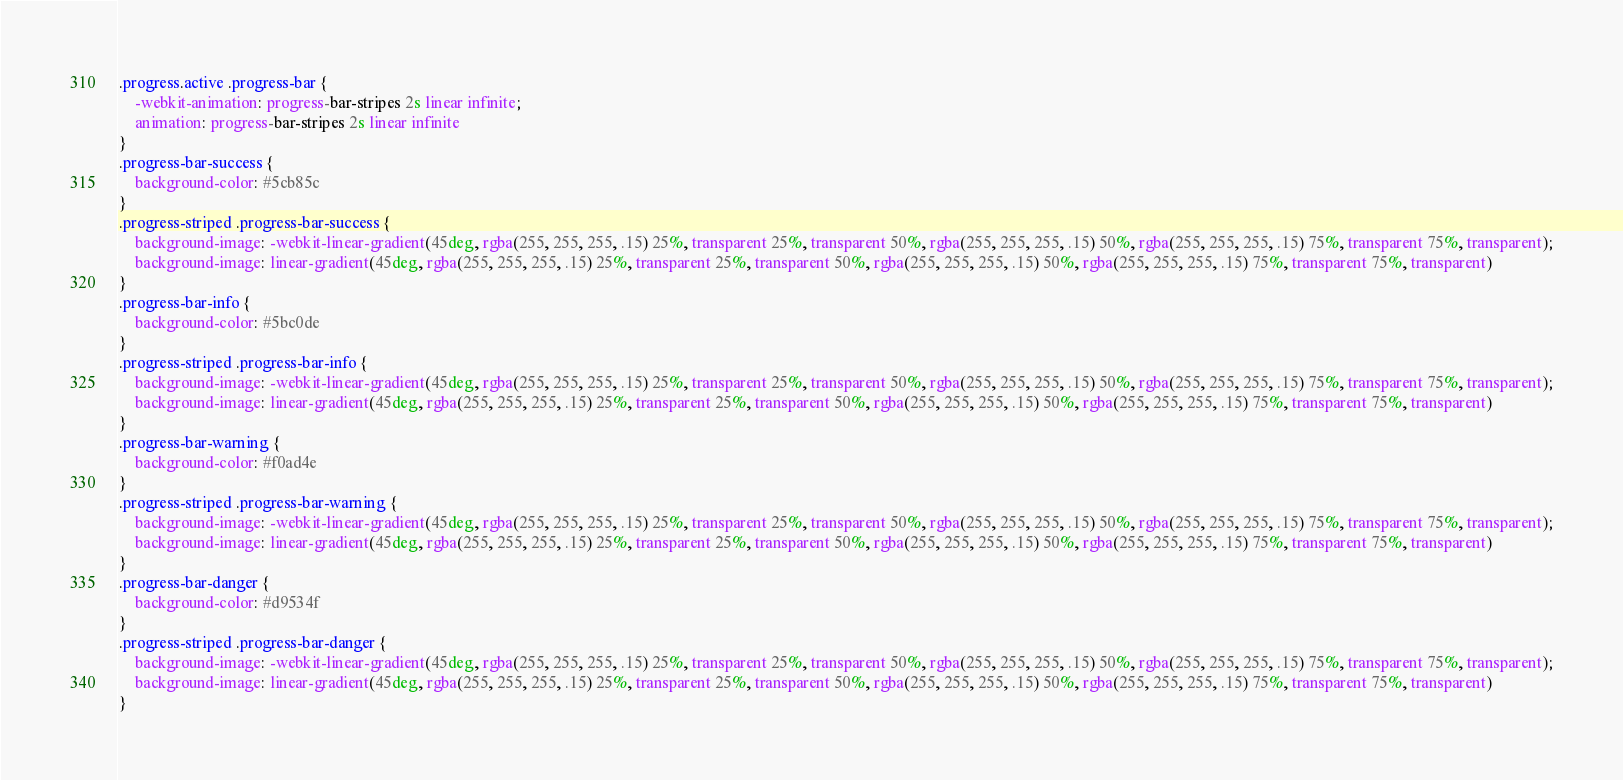<code> <loc_0><loc_0><loc_500><loc_500><_CSS_>.progress.active .progress-bar {
    -webkit-animation: progress-bar-stripes 2s linear infinite;
    animation: progress-bar-stripes 2s linear infinite
}
.progress-bar-success {
    background-color: #5cb85c
}
.progress-striped .progress-bar-success {
    background-image: -webkit-linear-gradient(45deg, rgba(255, 255, 255, .15) 25%, transparent 25%, transparent 50%, rgba(255, 255, 255, .15) 50%, rgba(255, 255, 255, .15) 75%, transparent 75%, transparent);
    background-image: linear-gradient(45deg, rgba(255, 255, 255, .15) 25%, transparent 25%, transparent 50%, rgba(255, 255, 255, .15) 50%, rgba(255, 255, 255, .15) 75%, transparent 75%, transparent)
}
.progress-bar-info {
    background-color: #5bc0de
}
.progress-striped .progress-bar-info {
    background-image: -webkit-linear-gradient(45deg, rgba(255, 255, 255, .15) 25%, transparent 25%, transparent 50%, rgba(255, 255, 255, .15) 50%, rgba(255, 255, 255, .15) 75%, transparent 75%, transparent);
    background-image: linear-gradient(45deg, rgba(255, 255, 255, .15) 25%, transparent 25%, transparent 50%, rgba(255, 255, 255, .15) 50%, rgba(255, 255, 255, .15) 75%, transparent 75%, transparent)
}
.progress-bar-warning {
    background-color: #f0ad4e
}
.progress-striped .progress-bar-warning {
    background-image: -webkit-linear-gradient(45deg, rgba(255, 255, 255, .15) 25%, transparent 25%, transparent 50%, rgba(255, 255, 255, .15) 50%, rgba(255, 255, 255, .15) 75%, transparent 75%, transparent);
    background-image: linear-gradient(45deg, rgba(255, 255, 255, .15) 25%, transparent 25%, transparent 50%, rgba(255, 255, 255, .15) 50%, rgba(255, 255, 255, .15) 75%, transparent 75%, transparent)
}
.progress-bar-danger {
    background-color: #d9534f
}
.progress-striped .progress-bar-danger {
    background-image: -webkit-linear-gradient(45deg, rgba(255, 255, 255, .15) 25%, transparent 25%, transparent 50%, rgba(255, 255, 255, .15) 50%, rgba(255, 255, 255, .15) 75%, transparent 75%, transparent);
    background-image: linear-gradient(45deg, rgba(255, 255, 255, .15) 25%, transparent 25%, transparent 50%, rgba(255, 255, 255, .15) 50%, rgba(255, 255, 255, .15) 75%, transparent 75%, transparent)
}</code> 